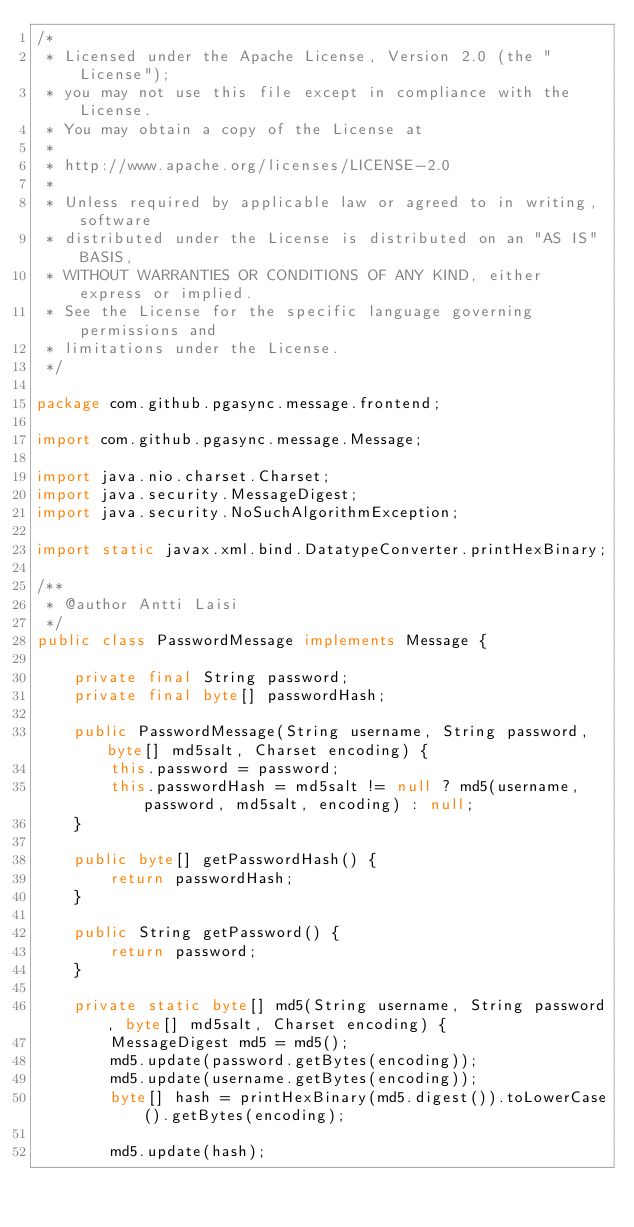Convert code to text. <code><loc_0><loc_0><loc_500><loc_500><_Java_>/*
 * Licensed under the Apache License, Version 2.0 (the "License");
 * you may not use this file except in compliance with the License.
 * You may obtain a copy of the License at
 *
 * http://www.apache.org/licenses/LICENSE-2.0
 *
 * Unless required by applicable law or agreed to in writing, software
 * distributed under the License is distributed on an "AS IS" BASIS,
 * WITHOUT WARRANTIES OR CONDITIONS OF ANY KIND, either express or implied.
 * See the License for the specific language governing permissions and
 * limitations under the License.
 */

package com.github.pgasync.message.frontend;

import com.github.pgasync.message.Message;

import java.nio.charset.Charset;
import java.security.MessageDigest;
import java.security.NoSuchAlgorithmException;

import static javax.xml.bind.DatatypeConverter.printHexBinary;

/**
 * @author Antti Laisi
 */
public class PasswordMessage implements Message {

    private final String password;
    private final byte[] passwordHash;

    public PasswordMessage(String username, String password, byte[] md5salt, Charset encoding) {
        this.password = password;
        this.passwordHash = md5salt != null ? md5(username, password, md5salt, encoding) : null;
    }

    public byte[] getPasswordHash() {
        return passwordHash;
    }

    public String getPassword() {
        return password;
    }

    private static byte[] md5(String username, String password, byte[] md5salt, Charset encoding) {
        MessageDigest md5 = md5();
        md5.update(password.getBytes(encoding));
        md5.update(username.getBytes(encoding));
        byte[] hash = printHexBinary(md5.digest()).toLowerCase().getBytes(encoding);

        md5.update(hash);</code> 